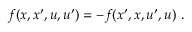<formula> <loc_0><loc_0><loc_500><loc_500>f ( x , x ^ { \prime } , u , u ^ { \prime } ) = - f ( x ^ { \prime } , x , u ^ { \prime } , u ) \ .</formula> 